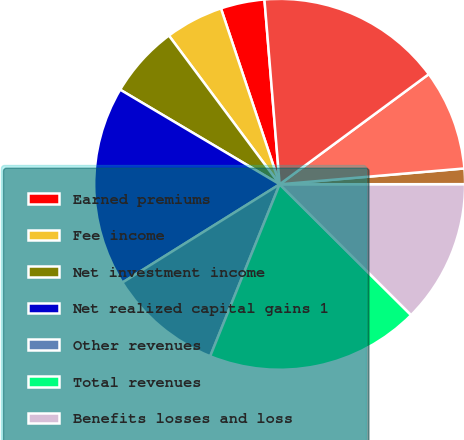Convert chart to OTSL. <chart><loc_0><loc_0><loc_500><loc_500><pie_chart><fcel>Earned premiums<fcel>Fee income<fcel>Net investment income<fcel>Net realized capital gains 1<fcel>Other revenues<fcel>Total revenues<fcel>Benefits losses and loss<fcel>Amortization of deferred<fcel>Insurance operating costs and<fcel>Reinsurance (gain) loss on<nl><fcel>3.82%<fcel>5.06%<fcel>6.29%<fcel>17.41%<fcel>10.0%<fcel>18.65%<fcel>12.47%<fcel>1.35%<fcel>8.76%<fcel>16.18%<nl></chart> 